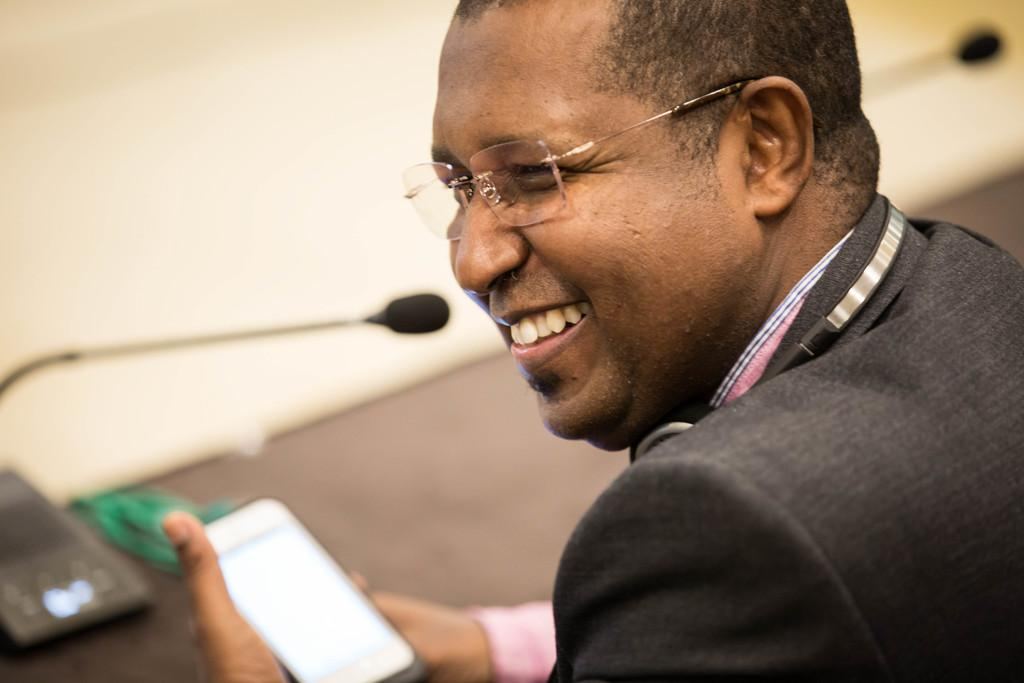What is the man in the image doing? The man is holding a mobile phone in his hand and smiling. What object is the man holding in his hand? The man is holding a mobile phone in his hand. Can you describe the man's facial expression? The man is smiling. What other object can be seen in the image? There is a microphone in the image. Where is the birthday cake located in the image? There is no birthday cake present in the image. What type of cord is connected to the microphone in the image? There is no cord connected to the microphone in the image. 